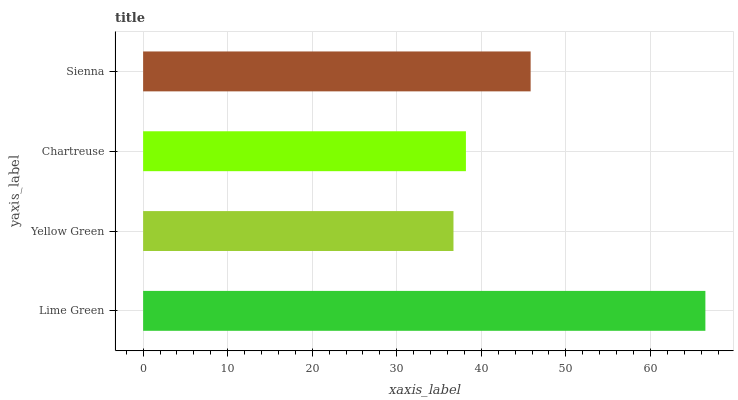Is Yellow Green the minimum?
Answer yes or no. Yes. Is Lime Green the maximum?
Answer yes or no. Yes. Is Chartreuse the minimum?
Answer yes or no. No. Is Chartreuse the maximum?
Answer yes or no. No. Is Chartreuse greater than Yellow Green?
Answer yes or no. Yes. Is Yellow Green less than Chartreuse?
Answer yes or no. Yes. Is Yellow Green greater than Chartreuse?
Answer yes or no. No. Is Chartreuse less than Yellow Green?
Answer yes or no. No. Is Sienna the high median?
Answer yes or no. Yes. Is Chartreuse the low median?
Answer yes or no. Yes. Is Chartreuse the high median?
Answer yes or no. No. Is Yellow Green the low median?
Answer yes or no. No. 